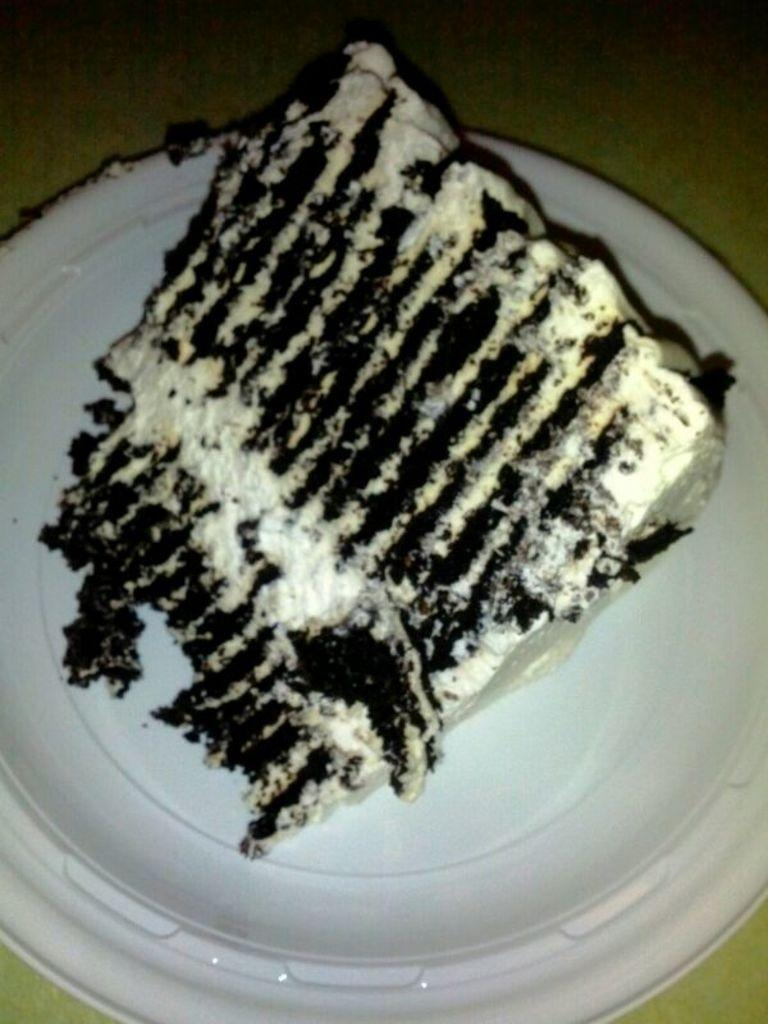What is present on the plate in the image? There is food in a plate in the image. Is there a jail visible in the image? No, there is no jail present in the image. What type of pie is being served on the plate? There is no pie visible in the image; it only shows food in a plate. 